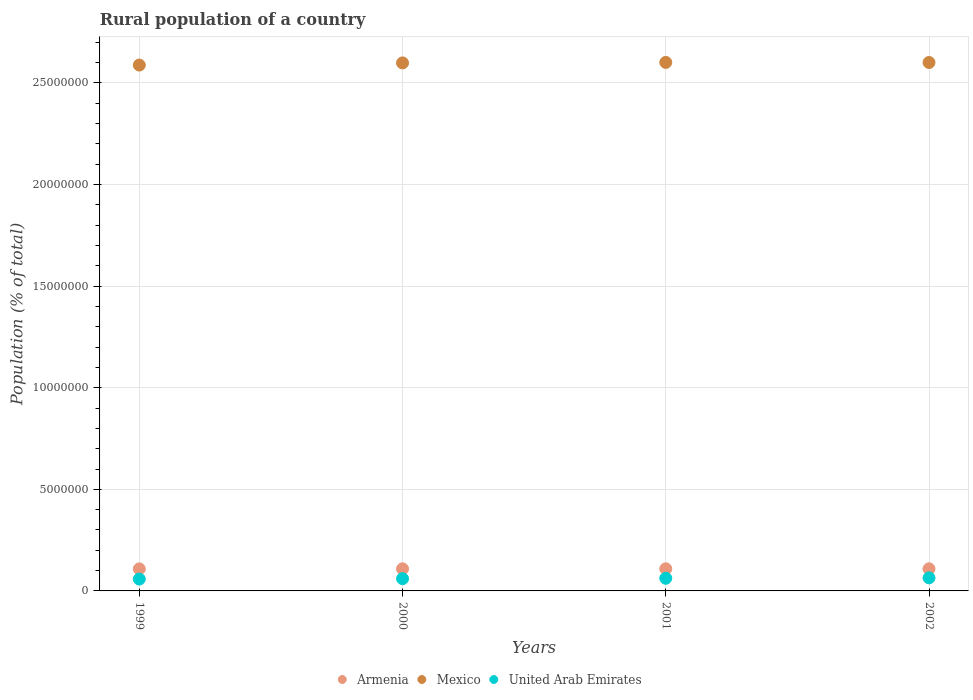How many different coloured dotlines are there?
Ensure brevity in your answer.  3. Is the number of dotlines equal to the number of legend labels?
Keep it short and to the point. Yes. What is the rural population in Armenia in 1999?
Give a very brief answer. 1.08e+06. Across all years, what is the maximum rural population in United Arab Emirates?
Give a very brief answer. 6.43e+05. Across all years, what is the minimum rural population in Armenia?
Give a very brief answer. 1.08e+06. In which year was the rural population in United Arab Emirates maximum?
Ensure brevity in your answer.  2002. What is the total rural population in Mexico in the graph?
Your answer should be compact. 1.04e+08. What is the difference between the rural population in Armenia in 1999 and that in 2000?
Provide a succinct answer. -2431. What is the difference between the rural population in Mexico in 2002 and the rural population in Armenia in 2000?
Ensure brevity in your answer.  2.49e+07. What is the average rural population in United Arab Emirates per year?
Give a very brief answer. 6.13e+05. In the year 2001, what is the difference between the rural population in Mexico and rural population in United Arab Emirates?
Your answer should be very brief. 2.54e+07. What is the ratio of the rural population in Mexico in 2000 to that in 2002?
Make the answer very short. 1. Is the rural population in Armenia in 1999 less than that in 2000?
Provide a succinct answer. Yes. Is the difference between the rural population in Mexico in 1999 and 2002 greater than the difference between the rural population in United Arab Emirates in 1999 and 2002?
Ensure brevity in your answer.  No. What is the difference between the highest and the second highest rural population in Mexico?
Your answer should be compact. 3770. What is the difference between the highest and the lowest rural population in Armenia?
Provide a short and direct response. 5355. Is the sum of the rural population in Armenia in 1999 and 2002 greater than the maximum rural population in Mexico across all years?
Offer a terse response. No. Is it the case that in every year, the sum of the rural population in Mexico and rural population in United Arab Emirates  is greater than the rural population in Armenia?
Your response must be concise. Yes. Does the rural population in Mexico monotonically increase over the years?
Give a very brief answer. No. How many dotlines are there?
Provide a short and direct response. 3. How many years are there in the graph?
Keep it short and to the point. 4. Does the graph contain any zero values?
Your response must be concise. No. How many legend labels are there?
Your response must be concise. 3. What is the title of the graph?
Offer a very short reply. Rural population of a country. What is the label or title of the X-axis?
Offer a very short reply. Years. What is the label or title of the Y-axis?
Ensure brevity in your answer.  Population (% of total). What is the Population (% of total) in Armenia in 1999?
Your response must be concise. 1.08e+06. What is the Population (% of total) in Mexico in 1999?
Keep it short and to the point. 2.59e+07. What is the Population (% of total) in United Arab Emirates in 1999?
Your answer should be compact. 5.82e+05. What is the Population (% of total) of Armenia in 2000?
Make the answer very short. 1.09e+06. What is the Population (% of total) of Mexico in 2000?
Offer a terse response. 2.60e+07. What is the Population (% of total) of United Arab Emirates in 2000?
Keep it short and to the point. 6.03e+05. What is the Population (% of total) of Armenia in 2001?
Offer a terse response. 1.09e+06. What is the Population (% of total) of Mexico in 2001?
Offer a very short reply. 2.60e+07. What is the Population (% of total) in United Arab Emirates in 2001?
Ensure brevity in your answer.  6.22e+05. What is the Population (% of total) of Armenia in 2002?
Offer a very short reply. 1.09e+06. What is the Population (% of total) in Mexico in 2002?
Keep it short and to the point. 2.60e+07. What is the Population (% of total) in United Arab Emirates in 2002?
Your answer should be very brief. 6.43e+05. Across all years, what is the maximum Population (% of total) in Armenia?
Provide a short and direct response. 1.09e+06. Across all years, what is the maximum Population (% of total) of Mexico?
Make the answer very short. 2.60e+07. Across all years, what is the maximum Population (% of total) in United Arab Emirates?
Your answer should be compact. 6.43e+05. Across all years, what is the minimum Population (% of total) in Armenia?
Offer a very short reply. 1.08e+06. Across all years, what is the minimum Population (% of total) in Mexico?
Offer a terse response. 2.59e+07. Across all years, what is the minimum Population (% of total) of United Arab Emirates?
Keep it short and to the point. 5.82e+05. What is the total Population (% of total) of Armenia in the graph?
Provide a succinct answer. 4.35e+06. What is the total Population (% of total) in Mexico in the graph?
Provide a short and direct response. 1.04e+08. What is the total Population (% of total) in United Arab Emirates in the graph?
Your response must be concise. 2.45e+06. What is the difference between the Population (% of total) of Armenia in 1999 and that in 2000?
Keep it short and to the point. -2431. What is the difference between the Population (% of total) of Mexico in 1999 and that in 2000?
Provide a succinct answer. -1.05e+05. What is the difference between the Population (% of total) of United Arab Emirates in 1999 and that in 2000?
Keep it short and to the point. -2.05e+04. What is the difference between the Population (% of total) of Armenia in 1999 and that in 2001?
Ensure brevity in your answer.  -5355. What is the difference between the Population (% of total) in Mexico in 1999 and that in 2001?
Offer a very short reply. -1.30e+05. What is the difference between the Population (% of total) in United Arab Emirates in 1999 and that in 2001?
Your answer should be compact. -4.02e+04. What is the difference between the Population (% of total) in Armenia in 1999 and that in 2002?
Keep it short and to the point. -3909. What is the difference between the Population (% of total) in Mexico in 1999 and that in 2002?
Your answer should be compact. -1.26e+05. What is the difference between the Population (% of total) of United Arab Emirates in 1999 and that in 2002?
Keep it short and to the point. -6.03e+04. What is the difference between the Population (% of total) in Armenia in 2000 and that in 2001?
Your answer should be compact. -2924. What is the difference between the Population (% of total) of Mexico in 2000 and that in 2001?
Ensure brevity in your answer.  -2.50e+04. What is the difference between the Population (% of total) of United Arab Emirates in 2000 and that in 2001?
Offer a very short reply. -1.97e+04. What is the difference between the Population (% of total) of Armenia in 2000 and that in 2002?
Provide a short and direct response. -1478. What is the difference between the Population (% of total) of Mexico in 2000 and that in 2002?
Give a very brief answer. -2.13e+04. What is the difference between the Population (% of total) in United Arab Emirates in 2000 and that in 2002?
Your answer should be compact. -3.98e+04. What is the difference between the Population (% of total) in Armenia in 2001 and that in 2002?
Your answer should be very brief. 1446. What is the difference between the Population (% of total) in Mexico in 2001 and that in 2002?
Make the answer very short. 3770. What is the difference between the Population (% of total) in United Arab Emirates in 2001 and that in 2002?
Keep it short and to the point. -2.01e+04. What is the difference between the Population (% of total) of Armenia in 1999 and the Population (% of total) of Mexico in 2000?
Offer a very short reply. -2.49e+07. What is the difference between the Population (% of total) of Armenia in 1999 and the Population (% of total) of United Arab Emirates in 2000?
Give a very brief answer. 4.82e+05. What is the difference between the Population (% of total) of Mexico in 1999 and the Population (% of total) of United Arab Emirates in 2000?
Your answer should be compact. 2.53e+07. What is the difference between the Population (% of total) in Armenia in 1999 and the Population (% of total) in Mexico in 2001?
Your answer should be compact. -2.49e+07. What is the difference between the Population (% of total) in Armenia in 1999 and the Population (% of total) in United Arab Emirates in 2001?
Make the answer very short. 4.62e+05. What is the difference between the Population (% of total) of Mexico in 1999 and the Population (% of total) of United Arab Emirates in 2001?
Offer a very short reply. 2.53e+07. What is the difference between the Population (% of total) in Armenia in 1999 and the Population (% of total) in Mexico in 2002?
Provide a succinct answer. -2.49e+07. What is the difference between the Population (% of total) of Armenia in 1999 and the Population (% of total) of United Arab Emirates in 2002?
Give a very brief answer. 4.42e+05. What is the difference between the Population (% of total) of Mexico in 1999 and the Population (% of total) of United Arab Emirates in 2002?
Your response must be concise. 2.52e+07. What is the difference between the Population (% of total) of Armenia in 2000 and the Population (% of total) of Mexico in 2001?
Your answer should be compact. -2.49e+07. What is the difference between the Population (% of total) of Armenia in 2000 and the Population (% of total) of United Arab Emirates in 2001?
Offer a terse response. 4.64e+05. What is the difference between the Population (% of total) in Mexico in 2000 and the Population (% of total) in United Arab Emirates in 2001?
Offer a very short reply. 2.54e+07. What is the difference between the Population (% of total) of Armenia in 2000 and the Population (% of total) of Mexico in 2002?
Provide a short and direct response. -2.49e+07. What is the difference between the Population (% of total) of Armenia in 2000 and the Population (% of total) of United Arab Emirates in 2002?
Your answer should be very brief. 4.44e+05. What is the difference between the Population (% of total) of Mexico in 2000 and the Population (% of total) of United Arab Emirates in 2002?
Offer a terse response. 2.53e+07. What is the difference between the Population (% of total) in Armenia in 2001 and the Population (% of total) in Mexico in 2002?
Keep it short and to the point. -2.49e+07. What is the difference between the Population (% of total) of Armenia in 2001 and the Population (% of total) of United Arab Emirates in 2002?
Give a very brief answer. 4.47e+05. What is the difference between the Population (% of total) of Mexico in 2001 and the Population (% of total) of United Arab Emirates in 2002?
Keep it short and to the point. 2.54e+07. What is the average Population (% of total) in Armenia per year?
Ensure brevity in your answer.  1.09e+06. What is the average Population (% of total) in Mexico per year?
Give a very brief answer. 2.60e+07. What is the average Population (% of total) of United Arab Emirates per year?
Offer a terse response. 6.13e+05. In the year 1999, what is the difference between the Population (% of total) in Armenia and Population (% of total) in Mexico?
Provide a short and direct response. -2.48e+07. In the year 1999, what is the difference between the Population (% of total) in Armenia and Population (% of total) in United Arab Emirates?
Keep it short and to the point. 5.02e+05. In the year 1999, what is the difference between the Population (% of total) in Mexico and Population (% of total) in United Arab Emirates?
Make the answer very short. 2.53e+07. In the year 2000, what is the difference between the Population (% of total) in Armenia and Population (% of total) in Mexico?
Ensure brevity in your answer.  -2.49e+07. In the year 2000, what is the difference between the Population (% of total) of Armenia and Population (% of total) of United Arab Emirates?
Offer a terse response. 4.84e+05. In the year 2000, what is the difference between the Population (% of total) in Mexico and Population (% of total) in United Arab Emirates?
Your answer should be compact. 2.54e+07. In the year 2001, what is the difference between the Population (% of total) in Armenia and Population (% of total) in Mexico?
Offer a very short reply. -2.49e+07. In the year 2001, what is the difference between the Population (% of total) of Armenia and Population (% of total) of United Arab Emirates?
Your answer should be very brief. 4.67e+05. In the year 2001, what is the difference between the Population (% of total) of Mexico and Population (% of total) of United Arab Emirates?
Offer a very short reply. 2.54e+07. In the year 2002, what is the difference between the Population (% of total) in Armenia and Population (% of total) in Mexico?
Provide a short and direct response. -2.49e+07. In the year 2002, what is the difference between the Population (% of total) in Armenia and Population (% of total) in United Arab Emirates?
Keep it short and to the point. 4.46e+05. In the year 2002, what is the difference between the Population (% of total) of Mexico and Population (% of total) of United Arab Emirates?
Ensure brevity in your answer.  2.54e+07. What is the ratio of the Population (% of total) of Mexico in 1999 to that in 2000?
Your answer should be very brief. 1. What is the ratio of the Population (% of total) of United Arab Emirates in 1999 to that in 2000?
Your answer should be compact. 0.97. What is the ratio of the Population (% of total) in Mexico in 1999 to that in 2001?
Your answer should be very brief. 0.99. What is the ratio of the Population (% of total) in United Arab Emirates in 1999 to that in 2001?
Offer a terse response. 0.94. What is the ratio of the Population (% of total) in Armenia in 1999 to that in 2002?
Give a very brief answer. 1. What is the ratio of the Population (% of total) of United Arab Emirates in 1999 to that in 2002?
Keep it short and to the point. 0.91. What is the ratio of the Population (% of total) of Armenia in 2000 to that in 2001?
Give a very brief answer. 1. What is the ratio of the Population (% of total) in United Arab Emirates in 2000 to that in 2001?
Your answer should be very brief. 0.97. What is the ratio of the Population (% of total) of Mexico in 2000 to that in 2002?
Make the answer very short. 1. What is the ratio of the Population (% of total) in United Arab Emirates in 2000 to that in 2002?
Ensure brevity in your answer.  0.94. What is the ratio of the Population (% of total) of Armenia in 2001 to that in 2002?
Offer a terse response. 1. What is the ratio of the Population (% of total) of Mexico in 2001 to that in 2002?
Offer a very short reply. 1. What is the ratio of the Population (% of total) in United Arab Emirates in 2001 to that in 2002?
Your answer should be compact. 0.97. What is the difference between the highest and the second highest Population (% of total) of Armenia?
Your answer should be very brief. 1446. What is the difference between the highest and the second highest Population (% of total) of Mexico?
Provide a succinct answer. 3770. What is the difference between the highest and the second highest Population (% of total) in United Arab Emirates?
Make the answer very short. 2.01e+04. What is the difference between the highest and the lowest Population (% of total) in Armenia?
Your response must be concise. 5355. What is the difference between the highest and the lowest Population (% of total) in Mexico?
Offer a very short reply. 1.30e+05. What is the difference between the highest and the lowest Population (% of total) of United Arab Emirates?
Give a very brief answer. 6.03e+04. 